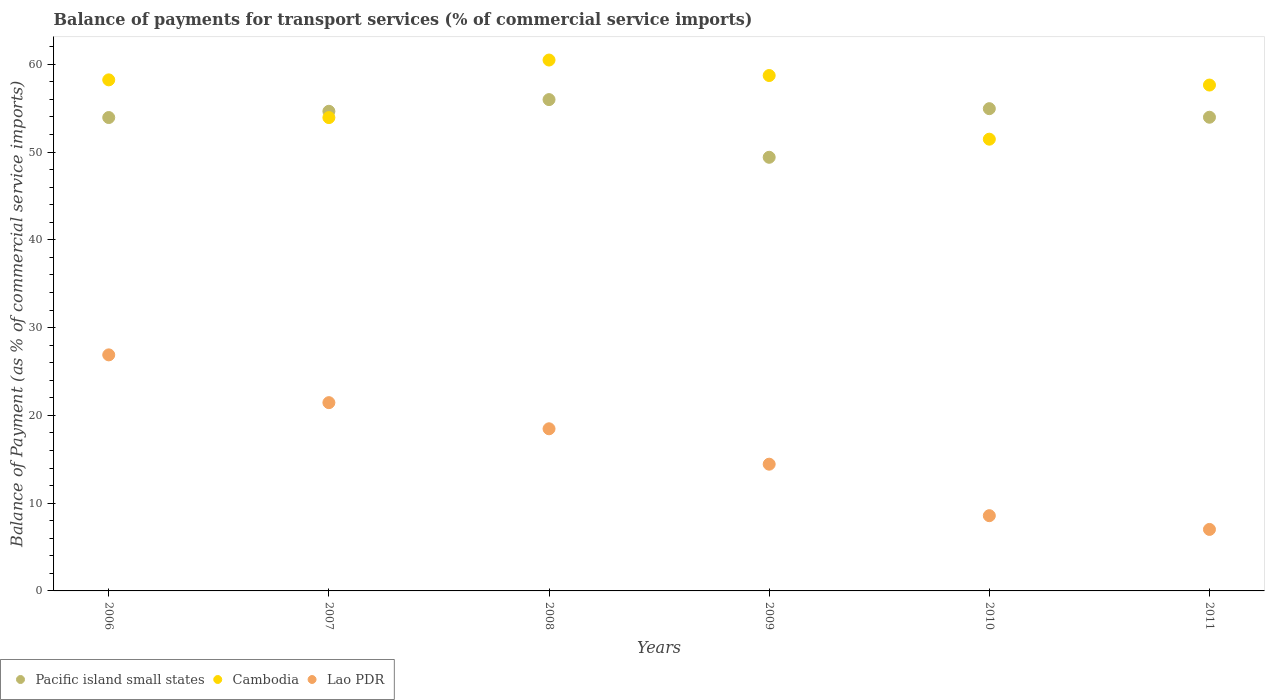Is the number of dotlines equal to the number of legend labels?
Offer a terse response. Yes. What is the balance of payments for transport services in Cambodia in 2011?
Provide a short and direct response. 57.63. Across all years, what is the maximum balance of payments for transport services in Cambodia?
Your response must be concise. 60.48. Across all years, what is the minimum balance of payments for transport services in Pacific island small states?
Keep it short and to the point. 49.4. What is the total balance of payments for transport services in Pacific island small states in the graph?
Offer a very short reply. 322.87. What is the difference between the balance of payments for transport services in Pacific island small states in 2006 and that in 2008?
Keep it short and to the point. -2.04. What is the difference between the balance of payments for transport services in Cambodia in 2010 and the balance of payments for transport services in Pacific island small states in 2007?
Make the answer very short. -3.18. What is the average balance of payments for transport services in Lao PDR per year?
Give a very brief answer. 16.14. In the year 2011, what is the difference between the balance of payments for transport services in Lao PDR and balance of payments for transport services in Pacific island small states?
Offer a very short reply. -46.96. In how many years, is the balance of payments for transport services in Pacific island small states greater than 36 %?
Your answer should be very brief. 6. What is the ratio of the balance of payments for transport services in Cambodia in 2006 to that in 2011?
Ensure brevity in your answer.  1.01. What is the difference between the highest and the second highest balance of payments for transport services in Pacific island small states?
Provide a short and direct response. 1.03. What is the difference between the highest and the lowest balance of payments for transport services in Pacific island small states?
Give a very brief answer. 6.57. Is the sum of the balance of payments for transport services in Cambodia in 2009 and 2011 greater than the maximum balance of payments for transport services in Lao PDR across all years?
Your answer should be very brief. Yes. Is it the case that in every year, the sum of the balance of payments for transport services in Cambodia and balance of payments for transport services in Lao PDR  is greater than the balance of payments for transport services in Pacific island small states?
Your answer should be very brief. Yes. Does the balance of payments for transport services in Pacific island small states monotonically increase over the years?
Provide a short and direct response. No. Is the balance of payments for transport services in Cambodia strictly less than the balance of payments for transport services in Pacific island small states over the years?
Provide a short and direct response. No. How many years are there in the graph?
Offer a very short reply. 6. Does the graph contain any zero values?
Provide a short and direct response. No. How many legend labels are there?
Your response must be concise. 3. What is the title of the graph?
Keep it short and to the point. Balance of payments for transport services (% of commercial service imports). What is the label or title of the X-axis?
Your response must be concise. Years. What is the label or title of the Y-axis?
Make the answer very short. Balance of Payment (as % of commercial service imports). What is the Balance of Payment (as % of commercial service imports) of Pacific island small states in 2006?
Your response must be concise. 53.93. What is the Balance of Payment (as % of commercial service imports) of Cambodia in 2006?
Provide a succinct answer. 58.22. What is the Balance of Payment (as % of commercial service imports) in Lao PDR in 2006?
Ensure brevity in your answer.  26.89. What is the Balance of Payment (as % of commercial service imports) of Pacific island small states in 2007?
Provide a short and direct response. 54.64. What is the Balance of Payment (as % of commercial service imports) of Cambodia in 2007?
Keep it short and to the point. 53.93. What is the Balance of Payment (as % of commercial service imports) of Lao PDR in 2007?
Ensure brevity in your answer.  21.45. What is the Balance of Payment (as % of commercial service imports) in Pacific island small states in 2008?
Offer a very short reply. 55.98. What is the Balance of Payment (as % of commercial service imports) of Cambodia in 2008?
Ensure brevity in your answer.  60.48. What is the Balance of Payment (as % of commercial service imports) of Lao PDR in 2008?
Offer a very short reply. 18.47. What is the Balance of Payment (as % of commercial service imports) in Pacific island small states in 2009?
Provide a succinct answer. 49.4. What is the Balance of Payment (as % of commercial service imports) in Cambodia in 2009?
Offer a very short reply. 58.72. What is the Balance of Payment (as % of commercial service imports) in Lao PDR in 2009?
Provide a short and direct response. 14.44. What is the Balance of Payment (as % of commercial service imports) in Pacific island small states in 2010?
Your answer should be compact. 54.94. What is the Balance of Payment (as % of commercial service imports) of Cambodia in 2010?
Provide a succinct answer. 51.47. What is the Balance of Payment (as % of commercial service imports) of Lao PDR in 2010?
Keep it short and to the point. 8.57. What is the Balance of Payment (as % of commercial service imports) in Pacific island small states in 2011?
Ensure brevity in your answer.  53.97. What is the Balance of Payment (as % of commercial service imports) of Cambodia in 2011?
Make the answer very short. 57.63. What is the Balance of Payment (as % of commercial service imports) of Lao PDR in 2011?
Your answer should be compact. 7.01. Across all years, what is the maximum Balance of Payment (as % of commercial service imports) of Pacific island small states?
Make the answer very short. 55.98. Across all years, what is the maximum Balance of Payment (as % of commercial service imports) of Cambodia?
Your answer should be very brief. 60.48. Across all years, what is the maximum Balance of Payment (as % of commercial service imports) of Lao PDR?
Your answer should be very brief. 26.89. Across all years, what is the minimum Balance of Payment (as % of commercial service imports) of Pacific island small states?
Offer a terse response. 49.4. Across all years, what is the minimum Balance of Payment (as % of commercial service imports) in Cambodia?
Your answer should be very brief. 51.47. Across all years, what is the minimum Balance of Payment (as % of commercial service imports) of Lao PDR?
Provide a short and direct response. 7.01. What is the total Balance of Payment (as % of commercial service imports) of Pacific island small states in the graph?
Provide a short and direct response. 322.87. What is the total Balance of Payment (as % of commercial service imports) in Cambodia in the graph?
Ensure brevity in your answer.  340.45. What is the total Balance of Payment (as % of commercial service imports) in Lao PDR in the graph?
Keep it short and to the point. 96.83. What is the difference between the Balance of Payment (as % of commercial service imports) in Pacific island small states in 2006 and that in 2007?
Provide a short and direct response. -0.71. What is the difference between the Balance of Payment (as % of commercial service imports) in Cambodia in 2006 and that in 2007?
Keep it short and to the point. 4.3. What is the difference between the Balance of Payment (as % of commercial service imports) in Lao PDR in 2006 and that in 2007?
Keep it short and to the point. 5.44. What is the difference between the Balance of Payment (as % of commercial service imports) of Pacific island small states in 2006 and that in 2008?
Your answer should be compact. -2.04. What is the difference between the Balance of Payment (as % of commercial service imports) of Cambodia in 2006 and that in 2008?
Provide a short and direct response. -2.26. What is the difference between the Balance of Payment (as % of commercial service imports) in Lao PDR in 2006 and that in 2008?
Provide a succinct answer. 8.42. What is the difference between the Balance of Payment (as % of commercial service imports) of Pacific island small states in 2006 and that in 2009?
Your answer should be very brief. 4.53. What is the difference between the Balance of Payment (as % of commercial service imports) in Cambodia in 2006 and that in 2009?
Your response must be concise. -0.49. What is the difference between the Balance of Payment (as % of commercial service imports) of Lao PDR in 2006 and that in 2009?
Your response must be concise. 12.45. What is the difference between the Balance of Payment (as % of commercial service imports) of Pacific island small states in 2006 and that in 2010?
Your response must be concise. -1.01. What is the difference between the Balance of Payment (as % of commercial service imports) in Cambodia in 2006 and that in 2010?
Your answer should be compact. 6.76. What is the difference between the Balance of Payment (as % of commercial service imports) of Lao PDR in 2006 and that in 2010?
Provide a succinct answer. 18.32. What is the difference between the Balance of Payment (as % of commercial service imports) in Pacific island small states in 2006 and that in 2011?
Provide a short and direct response. -0.03. What is the difference between the Balance of Payment (as % of commercial service imports) of Cambodia in 2006 and that in 2011?
Keep it short and to the point. 0.59. What is the difference between the Balance of Payment (as % of commercial service imports) of Lao PDR in 2006 and that in 2011?
Give a very brief answer. 19.89. What is the difference between the Balance of Payment (as % of commercial service imports) in Pacific island small states in 2007 and that in 2008?
Make the answer very short. -1.33. What is the difference between the Balance of Payment (as % of commercial service imports) in Cambodia in 2007 and that in 2008?
Keep it short and to the point. -6.56. What is the difference between the Balance of Payment (as % of commercial service imports) of Lao PDR in 2007 and that in 2008?
Your answer should be very brief. 2.98. What is the difference between the Balance of Payment (as % of commercial service imports) of Pacific island small states in 2007 and that in 2009?
Make the answer very short. 5.24. What is the difference between the Balance of Payment (as % of commercial service imports) of Cambodia in 2007 and that in 2009?
Provide a short and direct response. -4.79. What is the difference between the Balance of Payment (as % of commercial service imports) of Lao PDR in 2007 and that in 2009?
Offer a terse response. 7.01. What is the difference between the Balance of Payment (as % of commercial service imports) of Pacific island small states in 2007 and that in 2010?
Provide a short and direct response. -0.3. What is the difference between the Balance of Payment (as % of commercial service imports) of Cambodia in 2007 and that in 2010?
Offer a very short reply. 2.46. What is the difference between the Balance of Payment (as % of commercial service imports) of Lao PDR in 2007 and that in 2010?
Make the answer very short. 12.88. What is the difference between the Balance of Payment (as % of commercial service imports) of Pacific island small states in 2007 and that in 2011?
Keep it short and to the point. 0.68. What is the difference between the Balance of Payment (as % of commercial service imports) in Cambodia in 2007 and that in 2011?
Make the answer very short. -3.71. What is the difference between the Balance of Payment (as % of commercial service imports) of Lao PDR in 2007 and that in 2011?
Provide a succinct answer. 14.44. What is the difference between the Balance of Payment (as % of commercial service imports) of Pacific island small states in 2008 and that in 2009?
Ensure brevity in your answer.  6.57. What is the difference between the Balance of Payment (as % of commercial service imports) of Cambodia in 2008 and that in 2009?
Ensure brevity in your answer.  1.76. What is the difference between the Balance of Payment (as % of commercial service imports) in Lao PDR in 2008 and that in 2009?
Provide a succinct answer. 4.03. What is the difference between the Balance of Payment (as % of commercial service imports) of Pacific island small states in 2008 and that in 2010?
Offer a very short reply. 1.03. What is the difference between the Balance of Payment (as % of commercial service imports) of Cambodia in 2008 and that in 2010?
Give a very brief answer. 9.02. What is the difference between the Balance of Payment (as % of commercial service imports) of Lao PDR in 2008 and that in 2010?
Keep it short and to the point. 9.9. What is the difference between the Balance of Payment (as % of commercial service imports) in Pacific island small states in 2008 and that in 2011?
Your answer should be compact. 2.01. What is the difference between the Balance of Payment (as % of commercial service imports) of Cambodia in 2008 and that in 2011?
Provide a short and direct response. 2.85. What is the difference between the Balance of Payment (as % of commercial service imports) of Lao PDR in 2008 and that in 2011?
Give a very brief answer. 11.47. What is the difference between the Balance of Payment (as % of commercial service imports) in Pacific island small states in 2009 and that in 2010?
Your answer should be very brief. -5.54. What is the difference between the Balance of Payment (as % of commercial service imports) of Cambodia in 2009 and that in 2010?
Keep it short and to the point. 7.25. What is the difference between the Balance of Payment (as % of commercial service imports) of Lao PDR in 2009 and that in 2010?
Your answer should be very brief. 5.87. What is the difference between the Balance of Payment (as % of commercial service imports) of Pacific island small states in 2009 and that in 2011?
Your answer should be compact. -4.56. What is the difference between the Balance of Payment (as % of commercial service imports) in Cambodia in 2009 and that in 2011?
Your answer should be very brief. 1.08. What is the difference between the Balance of Payment (as % of commercial service imports) of Lao PDR in 2009 and that in 2011?
Ensure brevity in your answer.  7.43. What is the difference between the Balance of Payment (as % of commercial service imports) in Pacific island small states in 2010 and that in 2011?
Give a very brief answer. 0.98. What is the difference between the Balance of Payment (as % of commercial service imports) of Cambodia in 2010 and that in 2011?
Provide a succinct answer. -6.17. What is the difference between the Balance of Payment (as % of commercial service imports) of Lao PDR in 2010 and that in 2011?
Your response must be concise. 1.57. What is the difference between the Balance of Payment (as % of commercial service imports) in Pacific island small states in 2006 and the Balance of Payment (as % of commercial service imports) in Cambodia in 2007?
Make the answer very short. 0.01. What is the difference between the Balance of Payment (as % of commercial service imports) in Pacific island small states in 2006 and the Balance of Payment (as % of commercial service imports) in Lao PDR in 2007?
Keep it short and to the point. 32.48. What is the difference between the Balance of Payment (as % of commercial service imports) of Cambodia in 2006 and the Balance of Payment (as % of commercial service imports) of Lao PDR in 2007?
Ensure brevity in your answer.  36.77. What is the difference between the Balance of Payment (as % of commercial service imports) of Pacific island small states in 2006 and the Balance of Payment (as % of commercial service imports) of Cambodia in 2008?
Give a very brief answer. -6.55. What is the difference between the Balance of Payment (as % of commercial service imports) of Pacific island small states in 2006 and the Balance of Payment (as % of commercial service imports) of Lao PDR in 2008?
Offer a terse response. 35.46. What is the difference between the Balance of Payment (as % of commercial service imports) in Cambodia in 2006 and the Balance of Payment (as % of commercial service imports) in Lao PDR in 2008?
Keep it short and to the point. 39.75. What is the difference between the Balance of Payment (as % of commercial service imports) in Pacific island small states in 2006 and the Balance of Payment (as % of commercial service imports) in Cambodia in 2009?
Keep it short and to the point. -4.79. What is the difference between the Balance of Payment (as % of commercial service imports) of Pacific island small states in 2006 and the Balance of Payment (as % of commercial service imports) of Lao PDR in 2009?
Offer a very short reply. 39.49. What is the difference between the Balance of Payment (as % of commercial service imports) in Cambodia in 2006 and the Balance of Payment (as % of commercial service imports) in Lao PDR in 2009?
Provide a succinct answer. 43.79. What is the difference between the Balance of Payment (as % of commercial service imports) in Pacific island small states in 2006 and the Balance of Payment (as % of commercial service imports) in Cambodia in 2010?
Your response must be concise. 2.47. What is the difference between the Balance of Payment (as % of commercial service imports) of Pacific island small states in 2006 and the Balance of Payment (as % of commercial service imports) of Lao PDR in 2010?
Provide a short and direct response. 45.36. What is the difference between the Balance of Payment (as % of commercial service imports) of Cambodia in 2006 and the Balance of Payment (as % of commercial service imports) of Lao PDR in 2010?
Offer a terse response. 49.65. What is the difference between the Balance of Payment (as % of commercial service imports) in Pacific island small states in 2006 and the Balance of Payment (as % of commercial service imports) in Cambodia in 2011?
Make the answer very short. -3.7. What is the difference between the Balance of Payment (as % of commercial service imports) in Pacific island small states in 2006 and the Balance of Payment (as % of commercial service imports) in Lao PDR in 2011?
Keep it short and to the point. 46.93. What is the difference between the Balance of Payment (as % of commercial service imports) of Cambodia in 2006 and the Balance of Payment (as % of commercial service imports) of Lao PDR in 2011?
Make the answer very short. 51.22. What is the difference between the Balance of Payment (as % of commercial service imports) of Pacific island small states in 2007 and the Balance of Payment (as % of commercial service imports) of Cambodia in 2008?
Offer a very short reply. -5.84. What is the difference between the Balance of Payment (as % of commercial service imports) in Pacific island small states in 2007 and the Balance of Payment (as % of commercial service imports) in Lao PDR in 2008?
Give a very brief answer. 36.17. What is the difference between the Balance of Payment (as % of commercial service imports) in Cambodia in 2007 and the Balance of Payment (as % of commercial service imports) in Lao PDR in 2008?
Ensure brevity in your answer.  35.45. What is the difference between the Balance of Payment (as % of commercial service imports) of Pacific island small states in 2007 and the Balance of Payment (as % of commercial service imports) of Cambodia in 2009?
Your answer should be compact. -4.08. What is the difference between the Balance of Payment (as % of commercial service imports) of Pacific island small states in 2007 and the Balance of Payment (as % of commercial service imports) of Lao PDR in 2009?
Your answer should be very brief. 40.21. What is the difference between the Balance of Payment (as % of commercial service imports) of Cambodia in 2007 and the Balance of Payment (as % of commercial service imports) of Lao PDR in 2009?
Your answer should be compact. 39.49. What is the difference between the Balance of Payment (as % of commercial service imports) of Pacific island small states in 2007 and the Balance of Payment (as % of commercial service imports) of Cambodia in 2010?
Your response must be concise. 3.18. What is the difference between the Balance of Payment (as % of commercial service imports) of Pacific island small states in 2007 and the Balance of Payment (as % of commercial service imports) of Lao PDR in 2010?
Ensure brevity in your answer.  46.07. What is the difference between the Balance of Payment (as % of commercial service imports) in Cambodia in 2007 and the Balance of Payment (as % of commercial service imports) in Lao PDR in 2010?
Provide a short and direct response. 45.35. What is the difference between the Balance of Payment (as % of commercial service imports) in Pacific island small states in 2007 and the Balance of Payment (as % of commercial service imports) in Cambodia in 2011?
Offer a very short reply. -2.99. What is the difference between the Balance of Payment (as % of commercial service imports) of Pacific island small states in 2007 and the Balance of Payment (as % of commercial service imports) of Lao PDR in 2011?
Provide a short and direct response. 47.64. What is the difference between the Balance of Payment (as % of commercial service imports) of Cambodia in 2007 and the Balance of Payment (as % of commercial service imports) of Lao PDR in 2011?
Provide a succinct answer. 46.92. What is the difference between the Balance of Payment (as % of commercial service imports) in Pacific island small states in 2008 and the Balance of Payment (as % of commercial service imports) in Cambodia in 2009?
Your answer should be compact. -2.74. What is the difference between the Balance of Payment (as % of commercial service imports) of Pacific island small states in 2008 and the Balance of Payment (as % of commercial service imports) of Lao PDR in 2009?
Provide a succinct answer. 41.54. What is the difference between the Balance of Payment (as % of commercial service imports) of Cambodia in 2008 and the Balance of Payment (as % of commercial service imports) of Lao PDR in 2009?
Keep it short and to the point. 46.04. What is the difference between the Balance of Payment (as % of commercial service imports) of Pacific island small states in 2008 and the Balance of Payment (as % of commercial service imports) of Cambodia in 2010?
Offer a terse response. 4.51. What is the difference between the Balance of Payment (as % of commercial service imports) in Pacific island small states in 2008 and the Balance of Payment (as % of commercial service imports) in Lao PDR in 2010?
Make the answer very short. 47.4. What is the difference between the Balance of Payment (as % of commercial service imports) of Cambodia in 2008 and the Balance of Payment (as % of commercial service imports) of Lao PDR in 2010?
Your answer should be compact. 51.91. What is the difference between the Balance of Payment (as % of commercial service imports) in Pacific island small states in 2008 and the Balance of Payment (as % of commercial service imports) in Cambodia in 2011?
Your answer should be very brief. -1.66. What is the difference between the Balance of Payment (as % of commercial service imports) in Pacific island small states in 2008 and the Balance of Payment (as % of commercial service imports) in Lao PDR in 2011?
Ensure brevity in your answer.  48.97. What is the difference between the Balance of Payment (as % of commercial service imports) in Cambodia in 2008 and the Balance of Payment (as % of commercial service imports) in Lao PDR in 2011?
Make the answer very short. 53.48. What is the difference between the Balance of Payment (as % of commercial service imports) of Pacific island small states in 2009 and the Balance of Payment (as % of commercial service imports) of Cambodia in 2010?
Your answer should be compact. -2.06. What is the difference between the Balance of Payment (as % of commercial service imports) of Pacific island small states in 2009 and the Balance of Payment (as % of commercial service imports) of Lao PDR in 2010?
Your response must be concise. 40.83. What is the difference between the Balance of Payment (as % of commercial service imports) of Cambodia in 2009 and the Balance of Payment (as % of commercial service imports) of Lao PDR in 2010?
Provide a short and direct response. 50.15. What is the difference between the Balance of Payment (as % of commercial service imports) in Pacific island small states in 2009 and the Balance of Payment (as % of commercial service imports) in Cambodia in 2011?
Offer a terse response. -8.23. What is the difference between the Balance of Payment (as % of commercial service imports) in Pacific island small states in 2009 and the Balance of Payment (as % of commercial service imports) in Lao PDR in 2011?
Your response must be concise. 42.4. What is the difference between the Balance of Payment (as % of commercial service imports) in Cambodia in 2009 and the Balance of Payment (as % of commercial service imports) in Lao PDR in 2011?
Ensure brevity in your answer.  51.71. What is the difference between the Balance of Payment (as % of commercial service imports) of Pacific island small states in 2010 and the Balance of Payment (as % of commercial service imports) of Cambodia in 2011?
Give a very brief answer. -2.69. What is the difference between the Balance of Payment (as % of commercial service imports) of Pacific island small states in 2010 and the Balance of Payment (as % of commercial service imports) of Lao PDR in 2011?
Your response must be concise. 47.94. What is the difference between the Balance of Payment (as % of commercial service imports) in Cambodia in 2010 and the Balance of Payment (as % of commercial service imports) in Lao PDR in 2011?
Offer a terse response. 44.46. What is the average Balance of Payment (as % of commercial service imports) of Pacific island small states per year?
Provide a short and direct response. 53.81. What is the average Balance of Payment (as % of commercial service imports) of Cambodia per year?
Offer a very short reply. 56.74. What is the average Balance of Payment (as % of commercial service imports) of Lao PDR per year?
Your answer should be compact. 16.14. In the year 2006, what is the difference between the Balance of Payment (as % of commercial service imports) in Pacific island small states and Balance of Payment (as % of commercial service imports) in Cambodia?
Offer a very short reply. -4.29. In the year 2006, what is the difference between the Balance of Payment (as % of commercial service imports) in Pacific island small states and Balance of Payment (as % of commercial service imports) in Lao PDR?
Make the answer very short. 27.04. In the year 2006, what is the difference between the Balance of Payment (as % of commercial service imports) of Cambodia and Balance of Payment (as % of commercial service imports) of Lao PDR?
Your response must be concise. 31.33. In the year 2007, what is the difference between the Balance of Payment (as % of commercial service imports) in Pacific island small states and Balance of Payment (as % of commercial service imports) in Cambodia?
Ensure brevity in your answer.  0.72. In the year 2007, what is the difference between the Balance of Payment (as % of commercial service imports) of Pacific island small states and Balance of Payment (as % of commercial service imports) of Lao PDR?
Your answer should be compact. 33.19. In the year 2007, what is the difference between the Balance of Payment (as % of commercial service imports) of Cambodia and Balance of Payment (as % of commercial service imports) of Lao PDR?
Ensure brevity in your answer.  32.48. In the year 2008, what is the difference between the Balance of Payment (as % of commercial service imports) of Pacific island small states and Balance of Payment (as % of commercial service imports) of Cambodia?
Your answer should be very brief. -4.51. In the year 2008, what is the difference between the Balance of Payment (as % of commercial service imports) in Pacific island small states and Balance of Payment (as % of commercial service imports) in Lao PDR?
Your answer should be very brief. 37.5. In the year 2008, what is the difference between the Balance of Payment (as % of commercial service imports) of Cambodia and Balance of Payment (as % of commercial service imports) of Lao PDR?
Provide a short and direct response. 42.01. In the year 2009, what is the difference between the Balance of Payment (as % of commercial service imports) of Pacific island small states and Balance of Payment (as % of commercial service imports) of Cambodia?
Provide a short and direct response. -9.32. In the year 2009, what is the difference between the Balance of Payment (as % of commercial service imports) in Pacific island small states and Balance of Payment (as % of commercial service imports) in Lao PDR?
Keep it short and to the point. 34.97. In the year 2009, what is the difference between the Balance of Payment (as % of commercial service imports) of Cambodia and Balance of Payment (as % of commercial service imports) of Lao PDR?
Offer a very short reply. 44.28. In the year 2010, what is the difference between the Balance of Payment (as % of commercial service imports) in Pacific island small states and Balance of Payment (as % of commercial service imports) in Cambodia?
Keep it short and to the point. 3.48. In the year 2010, what is the difference between the Balance of Payment (as % of commercial service imports) of Pacific island small states and Balance of Payment (as % of commercial service imports) of Lao PDR?
Your answer should be compact. 46.37. In the year 2010, what is the difference between the Balance of Payment (as % of commercial service imports) of Cambodia and Balance of Payment (as % of commercial service imports) of Lao PDR?
Your answer should be very brief. 42.89. In the year 2011, what is the difference between the Balance of Payment (as % of commercial service imports) of Pacific island small states and Balance of Payment (as % of commercial service imports) of Cambodia?
Your response must be concise. -3.67. In the year 2011, what is the difference between the Balance of Payment (as % of commercial service imports) in Pacific island small states and Balance of Payment (as % of commercial service imports) in Lao PDR?
Keep it short and to the point. 46.96. In the year 2011, what is the difference between the Balance of Payment (as % of commercial service imports) in Cambodia and Balance of Payment (as % of commercial service imports) in Lao PDR?
Your response must be concise. 50.63. What is the ratio of the Balance of Payment (as % of commercial service imports) of Cambodia in 2006 to that in 2007?
Ensure brevity in your answer.  1.08. What is the ratio of the Balance of Payment (as % of commercial service imports) of Lao PDR in 2006 to that in 2007?
Your answer should be very brief. 1.25. What is the ratio of the Balance of Payment (as % of commercial service imports) of Pacific island small states in 2006 to that in 2008?
Provide a short and direct response. 0.96. What is the ratio of the Balance of Payment (as % of commercial service imports) in Cambodia in 2006 to that in 2008?
Give a very brief answer. 0.96. What is the ratio of the Balance of Payment (as % of commercial service imports) of Lao PDR in 2006 to that in 2008?
Your answer should be very brief. 1.46. What is the ratio of the Balance of Payment (as % of commercial service imports) in Pacific island small states in 2006 to that in 2009?
Make the answer very short. 1.09. What is the ratio of the Balance of Payment (as % of commercial service imports) of Lao PDR in 2006 to that in 2009?
Your answer should be compact. 1.86. What is the ratio of the Balance of Payment (as % of commercial service imports) in Pacific island small states in 2006 to that in 2010?
Ensure brevity in your answer.  0.98. What is the ratio of the Balance of Payment (as % of commercial service imports) in Cambodia in 2006 to that in 2010?
Your response must be concise. 1.13. What is the ratio of the Balance of Payment (as % of commercial service imports) of Lao PDR in 2006 to that in 2010?
Your response must be concise. 3.14. What is the ratio of the Balance of Payment (as % of commercial service imports) of Cambodia in 2006 to that in 2011?
Give a very brief answer. 1.01. What is the ratio of the Balance of Payment (as % of commercial service imports) in Lao PDR in 2006 to that in 2011?
Keep it short and to the point. 3.84. What is the ratio of the Balance of Payment (as % of commercial service imports) of Pacific island small states in 2007 to that in 2008?
Make the answer very short. 0.98. What is the ratio of the Balance of Payment (as % of commercial service imports) of Cambodia in 2007 to that in 2008?
Provide a succinct answer. 0.89. What is the ratio of the Balance of Payment (as % of commercial service imports) of Lao PDR in 2007 to that in 2008?
Give a very brief answer. 1.16. What is the ratio of the Balance of Payment (as % of commercial service imports) of Pacific island small states in 2007 to that in 2009?
Offer a terse response. 1.11. What is the ratio of the Balance of Payment (as % of commercial service imports) in Cambodia in 2007 to that in 2009?
Make the answer very short. 0.92. What is the ratio of the Balance of Payment (as % of commercial service imports) in Lao PDR in 2007 to that in 2009?
Offer a very short reply. 1.49. What is the ratio of the Balance of Payment (as % of commercial service imports) in Pacific island small states in 2007 to that in 2010?
Your answer should be very brief. 0.99. What is the ratio of the Balance of Payment (as % of commercial service imports) of Cambodia in 2007 to that in 2010?
Offer a very short reply. 1.05. What is the ratio of the Balance of Payment (as % of commercial service imports) in Lao PDR in 2007 to that in 2010?
Ensure brevity in your answer.  2.5. What is the ratio of the Balance of Payment (as % of commercial service imports) of Pacific island small states in 2007 to that in 2011?
Your answer should be very brief. 1.01. What is the ratio of the Balance of Payment (as % of commercial service imports) in Cambodia in 2007 to that in 2011?
Your answer should be compact. 0.94. What is the ratio of the Balance of Payment (as % of commercial service imports) in Lao PDR in 2007 to that in 2011?
Ensure brevity in your answer.  3.06. What is the ratio of the Balance of Payment (as % of commercial service imports) of Pacific island small states in 2008 to that in 2009?
Offer a very short reply. 1.13. What is the ratio of the Balance of Payment (as % of commercial service imports) in Lao PDR in 2008 to that in 2009?
Provide a short and direct response. 1.28. What is the ratio of the Balance of Payment (as % of commercial service imports) of Pacific island small states in 2008 to that in 2010?
Offer a terse response. 1.02. What is the ratio of the Balance of Payment (as % of commercial service imports) of Cambodia in 2008 to that in 2010?
Provide a succinct answer. 1.18. What is the ratio of the Balance of Payment (as % of commercial service imports) in Lao PDR in 2008 to that in 2010?
Your answer should be compact. 2.15. What is the ratio of the Balance of Payment (as % of commercial service imports) of Pacific island small states in 2008 to that in 2011?
Your response must be concise. 1.04. What is the ratio of the Balance of Payment (as % of commercial service imports) of Cambodia in 2008 to that in 2011?
Keep it short and to the point. 1.05. What is the ratio of the Balance of Payment (as % of commercial service imports) of Lao PDR in 2008 to that in 2011?
Offer a very short reply. 2.64. What is the ratio of the Balance of Payment (as % of commercial service imports) in Pacific island small states in 2009 to that in 2010?
Provide a succinct answer. 0.9. What is the ratio of the Balance of Payment (as % of commercial service imports) in Cambodia in 2009 to that in 2010?
Ensure brevity in your answer.  1.14. What is the ratio of the Balance of Payment (as % of commercial service imports) of Lao PDR in 2009 to that in 2010?
Give a very brief answer. 1.68. What is the ratio of the Balance of Payment (as % of commercial service imports) in Pacific island small states in 2009 to that in 2011?
Your answer should be compact. 0.92. What is the ratio of the Balance of Payment (as % of commercial service imports) of Cambodia in 2009 to that in 2011?
Give a very brief answer. 1.02. What is the ratio of the Balance of Payment (as % of commercial service imports) in Lao PDR in 2009 to that in 2011?
Provide a short and direct response. 2.06. What is the ratio of the Balance of Payment (as % of commercial service imports) of Pacific island small states in 2010 to that in 2011?
Offer a very short reply. 1.02. What is the ratio of the Balance of Payment (as % of commercial service imports) in Cambodia in 2010 to that in 2011?
Give a very brief answer. 0.89. What is the ratio of the Balance of Payment (as % of commercial service imports) of Lao PDR in 2010 to that in 2011?
Offer a terse response. 1.22. What is the difference between the highest and the second highest Balance of Payment (as % of commercial service imports) of Pacific island small states?
Provide a short and direct response. 1.03. What is the difference between the highest and the second highest Balance of Payment (as % of commercial service imports) of Cambodia?
Your response must be concise. 1.76. What is the difference between the highest and the second highest Balance of Payment (as % of commercial service imports) in Lao PDR?
Your answer should be very brief. 5.44. What is the difference between the highest and the lowest Balance of Payment (as % of commercial service imports) of Pacific island small states?
Offer a terse response. 6.57. What is the difference between the highest and the lowest Balance of Payment (as % of commercial service imports) in Cambodia?
Make the answer very short. 9.02. What is the difference between the highest and the lowest Balance of Payment (as % of commercial service imports) of Lao PDR?
Provide a succinct answer. 19.89. 